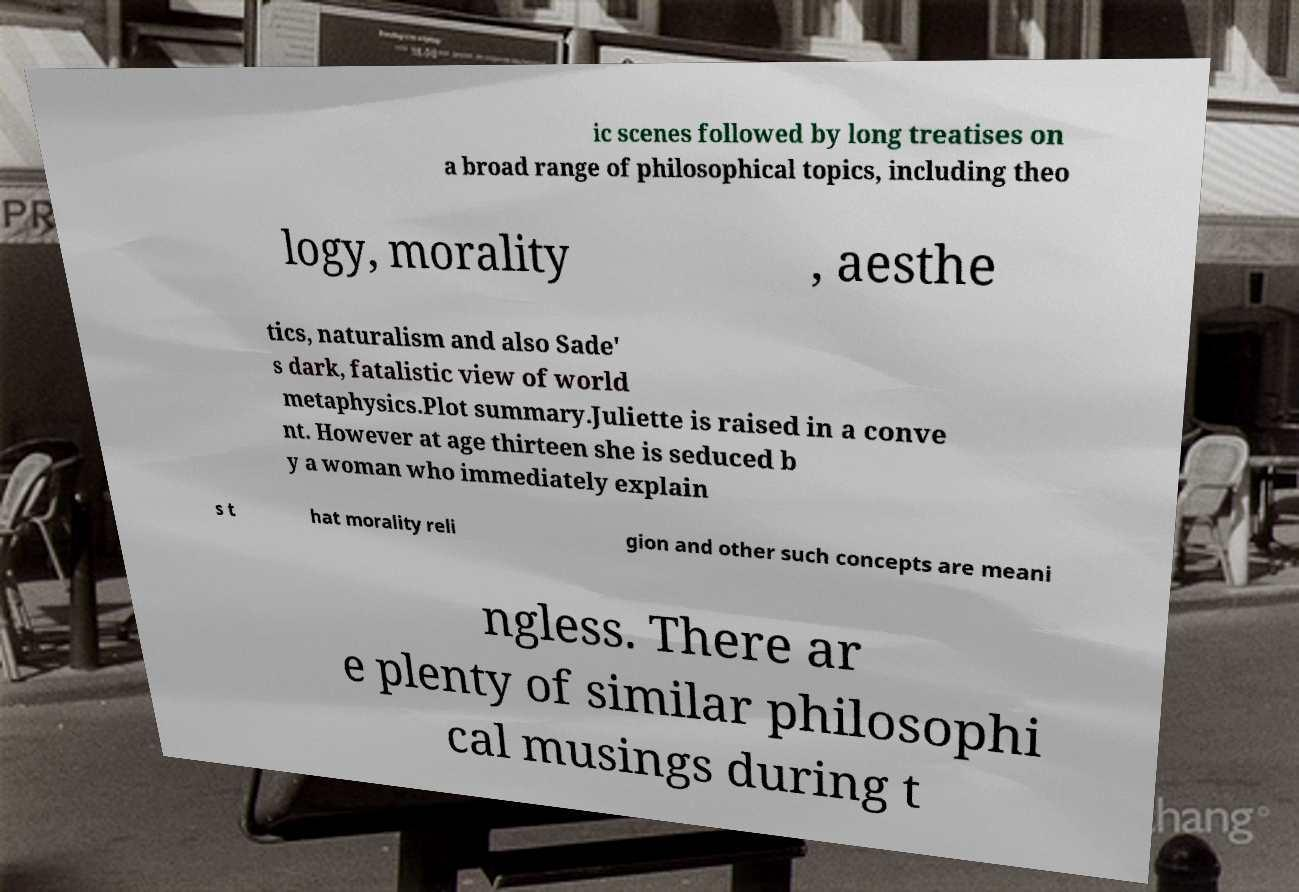For documentation purposes, I need the text within this image transcribed. Could you provide that? ic scenes followed by long treatises on a broad range of philosophical topics, including theo logy, morality , aesthe tics, naturalism and also Sade' s dark, fatalistic view of world metaphysics.Plot summary.Juliette is raised in a conve nt. However at age thirteen she is seduced b y a woman who immediately explain s t hat morality reli gion and other such concepts are meani ngless. There ar e plenty of similar philosophi cal musings during t 